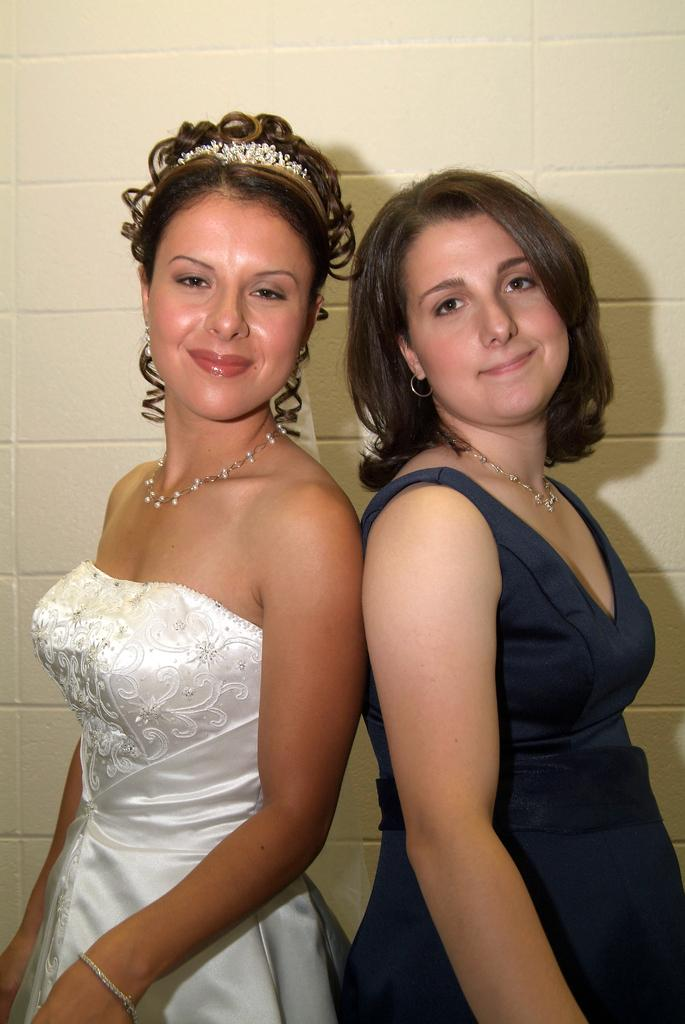How many people are present in the image? There are two women standing in the image. What can be seen in the background of the image? There is a wall in the background of the image. What type of railway is visible in the image? There is no railway present in the image; it only features two women and a wall in the background. 